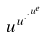<formula> <loc_0><loc_0><loc_500><loc_500>u ^ { u ^ { \cdot ^ { \cdot ^ { u ^ { e } } } } }</formula> 